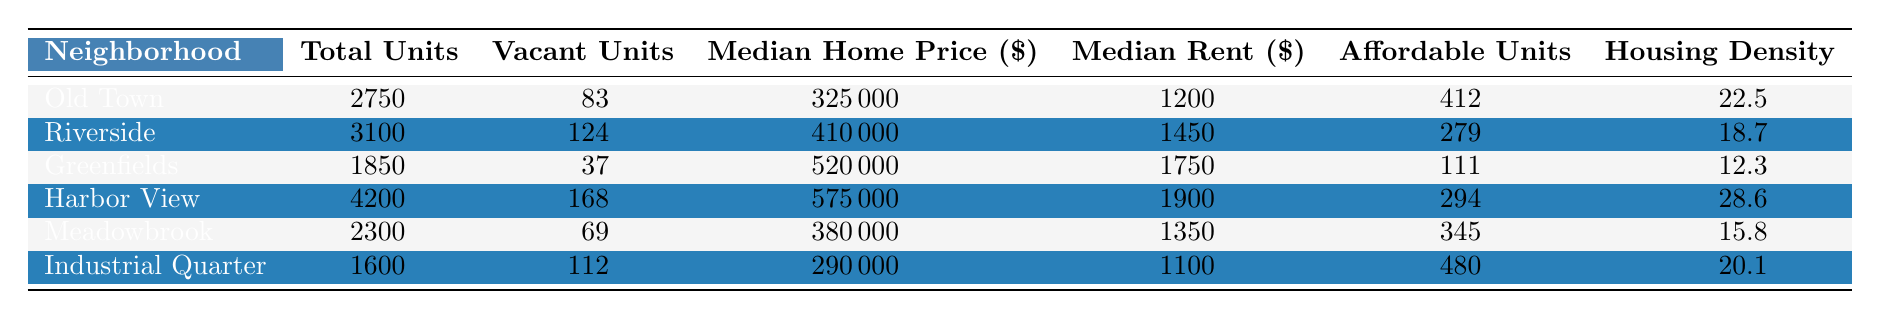What is the median home price in Old Town? By checking the row for Old Town in the table, we see the median home price listed as $325,000.
Answer: $325,000 How many total units are there in Riverside? Looking at the Riverside row, the total number of units is specified as 3,100.
Answer: 3,100 Which neighborhood has the highest median rent? Scanning through the median rent column, we find Harbor View has the highest rent at $1,900 compared to the others.
Answer: Harbor View What is the total number of affordable units across all neighborhoods? To find the total, we sum up the affordable units: 412 (Old Town) + 279 (Riverside) + 111 (Greenfields) + 294 (Harbor View) + 345 (Meadowbrook) + 480 (Industrial Quarter) = 1,921.
Answer: 1,921 Which neighborhood has the lowest housing density? By reviewing the housing density column, we see Greenfields with a density of 12.3, the lowest among all neighborhoods.
Answer: Greenfields Are there more vacant units in Harbor View than in Old Town? Harbor View has 168 vacant units and Old Town has 83. Since 168 is greater than 83, the statement is true.
Answer: Yes What is the difference in median home price between Riverside and Meadowbrook? Riverside has a median home price of $410,000 and Meadowbrook has $380,000. The difference is $410,000 - $380,000 = $30,000.
Answer: $30,000 Is the number of total units in the Industrial Quarter less than the average total units of all neighborhoods? The average total units can be calculated as (2750 + 3100 + 1850 + 4200 + 2300 + 1600) / 6 = 2,791.67. Since Industrial Quarter has 1,600, and 1,600 is less than 2,791.67, the answer is yes.
Answer: Yes Calculate the ratio of affordable units to total units in Riverside. For Riverside, the affordable units are 279 and total units are 3100. The ratio is 279 / 3100 = 0.09 or 9%.
Answer: 0.09 (or 9%) Which neighborhood has the highest number of vacant units? By examining the vacant units column, we see Harbor View with 168 vacant units is the highest.
Answer: Harbor View 